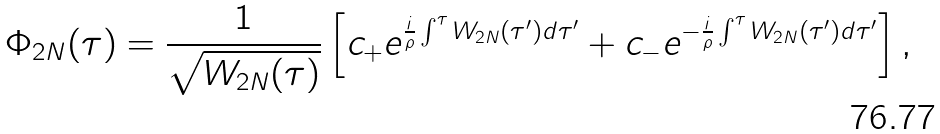Convert formula to latex. <formula><loc_0><loc_0><loc_500><loc_500>\Phi _ { 2 N } ( \tau ) = \frac { 1 } { \sqrt { W _ { 2 N } ( \tau ) } } \left [ c _ { + } e ^ { \frac { i } { \rho } \int ^ { \tau } W _ { 2 N } ( \tau ^ { \prime } ) d \tau ^ { \prime } } + c _ { - } e ^ { - \frac { i } { \rho } \int ^ { \tau } W _ { 2 N } ( \tau ^ { \prime } ) d \tau ^ { \prime } } \right ] ,</formula> 